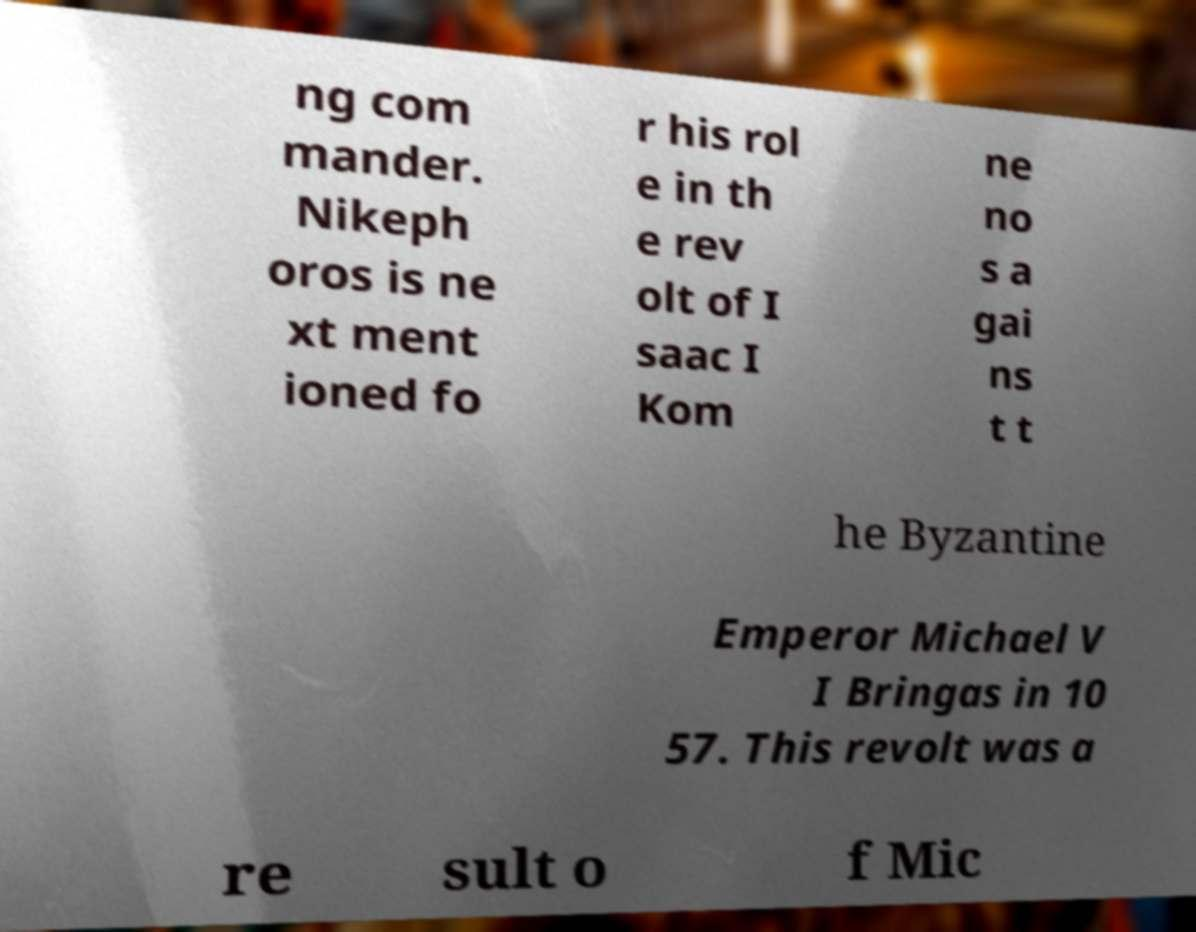Please read and relay the text visible in this image. What does it say? ng com mander. Nikeph oros is ne xt ment ioned fo r his rol e in th e rev olt of I saac I Kom ne no s a gai ns t t he Byzantine Emperor Michael V I Bringas in 10 57. This revolt was a re sult o f Mic 